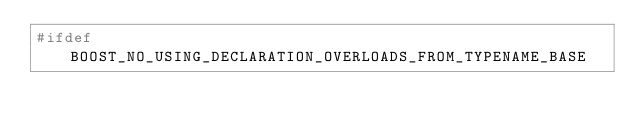Convert code to text. <code><loc_0><loc_0><loc_500><loc_500><_C++_>#ifdef BOOST_NO_USING_DECLARATION_OVERLOADS_FROM_TYPENAME_BASE</code> 